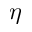Convert formula to latex. <formula><loc_0><loc_0><loc_500><loc_500>\eta</formula> 